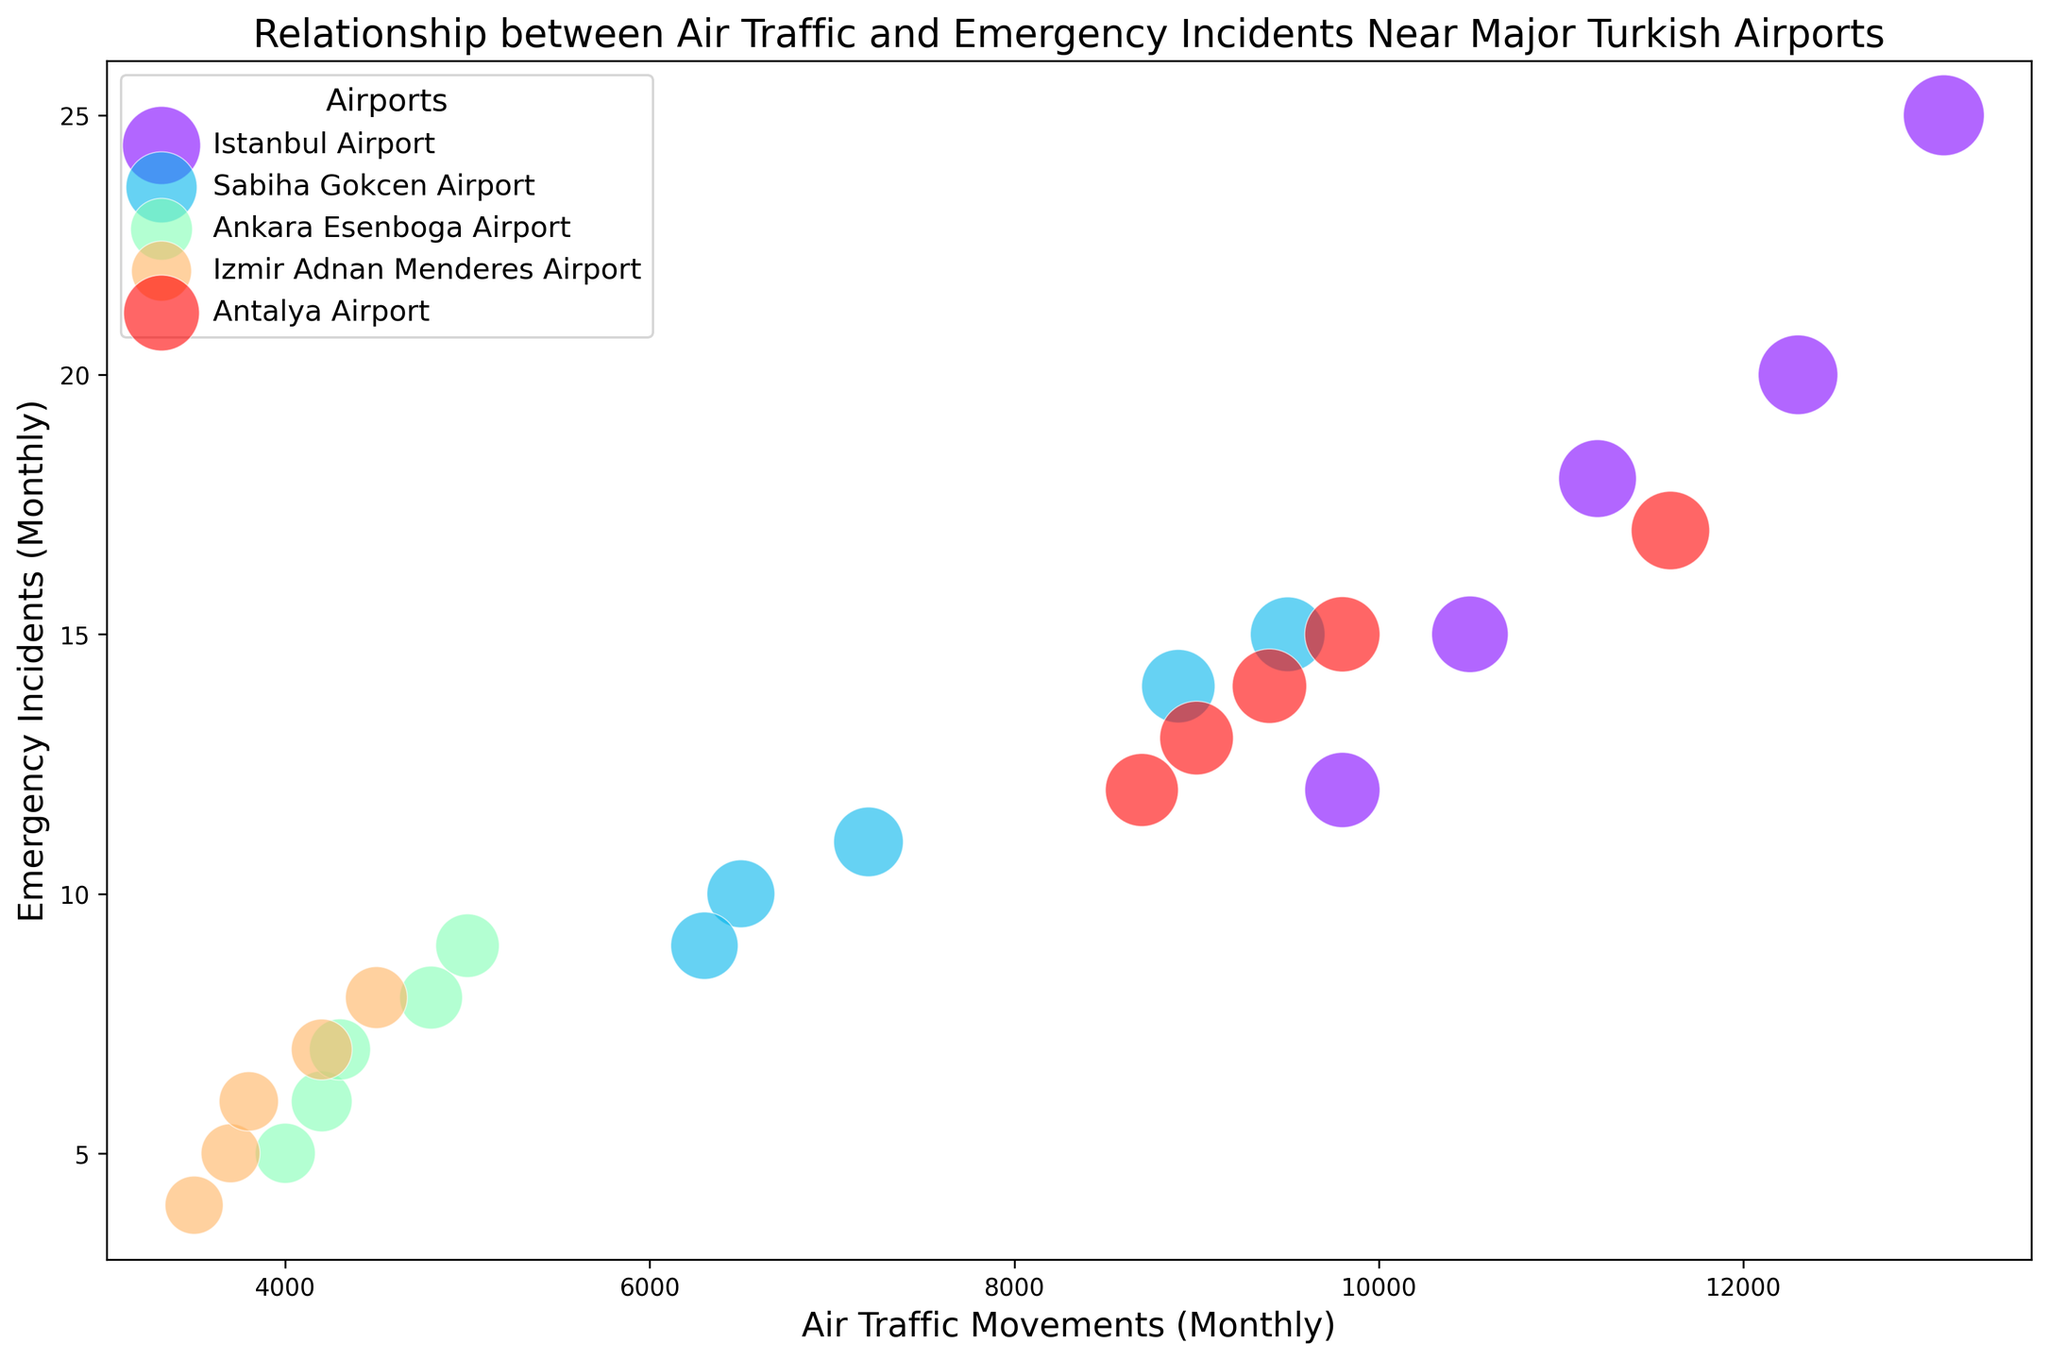What is the airport with the highest number of emergency incidents in May? Look for the bubble in May for each airport and compare the number of emergency incidents. Istanbul Airport has the largest bubble in May with 25 incidents.
Answer: Istanbul Airport Which airport has the smallest bubble in March and how many emergency incidents does it represent? Identify the smallest bubble in March. The smallest bubble is at Izmir Adnan Menderes Airport, representing 6 emergency incidents.
Answer: Izmir Adnan Menderes Airport, 6 Between Istanbul Airport and Antalya Airport in April, which has more emergency incidents and by how many? Compare the number of emergency incidents for both airports in April. Istanbul Airport has 20 incidents, and Antalya Airport has 15 incidents, so the difference is 5 incidents.
Answer: Istanbul Airport, 5 Is there a positive correlation between air traffic movements and emergency incidents at Istanbul Airport? Observe the trend of the bubbles representing Istanbul Airport over the months. As the air traffic movements increase, the number of emergency incidents also increases, indicating a positive correlation.
Answer: Yes In February, which airport has the highest air traffic movements, and how many emergency incidents occurred there? Check the bubbles for each airport in February and identify the one with the largest air traffic movements. Istanbul Airport has the highest with 9800 movements and 12 emergency incidents.
Answer: Istanbul Airport, 12 Which two airports have the highest number of emergency incidents in January and what are the corresponding air traffic movements? Identify the two bubbles with the largest number of emergency incidents in January. Istanbul Airport (10500 movements) and Antalya Airport (9000 movements) have the highest numbers with 15 and 13 incidents respectively.
Answer: Istanbul Airport, 10500 and Antalya Airport, 9000 Compare the total number of emergency incidents in January for Sabiha Gökçen Airport and Ankara Esenboğa Airport. Which one has more and by how much? Sum each airport's January emergency incidents. Sabiha Gökçen Airport has 10, and Ankara Esenboğa Airport has 6, so Sabiha Gökçen has 4 more incidents.
Answer: Sabiha Gökçen Airport, 4 Which airport has a consistent increase in emergency incidents from January to May? Look at the bubbles' sizes from January to May for each airport. The bubbles for Istanbul Airport and Izmir Adnan Menderes Airport consistently increase.
Answer: Istanbul Airport and Izmir Adnan Menderes Airport In May, which airport has the second-highest air traffic movements, and how many emergency incidents does it have? Identify the airport with the second-largest bubble for May. Antalya Airport has the second-highest air traffic movements with 11600 and 17 emergency incidents.
Answer: Antalya Airport, 17 What is the average number of emergency incidents for Sabiha Gökçen Airport from January to May? Sum the emergency incidents from January to May for Sabiha Gökçen Airport (10 + 9 + 11 + 14 + 15) and divide by 5 to find the average. The sum is 59, resulting in an average of 59/5 = 11.8 incidents.
Answer: 11.8 